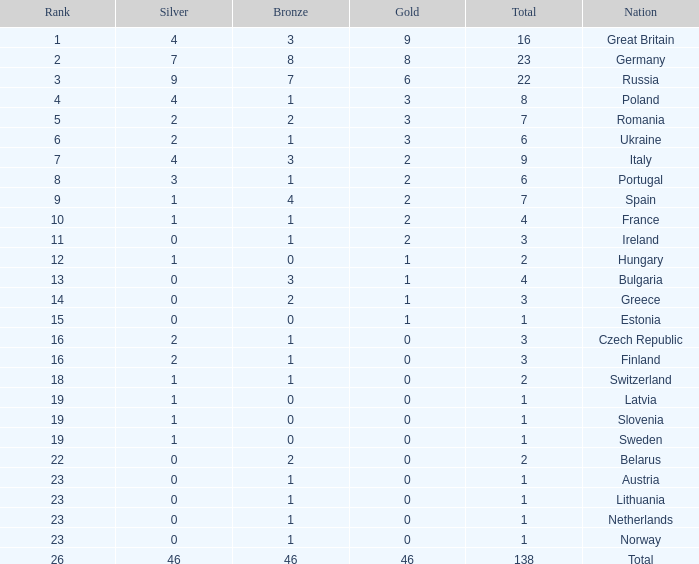What is the average rank when the bronze is larger than 1, and silver is less than 0? None. 